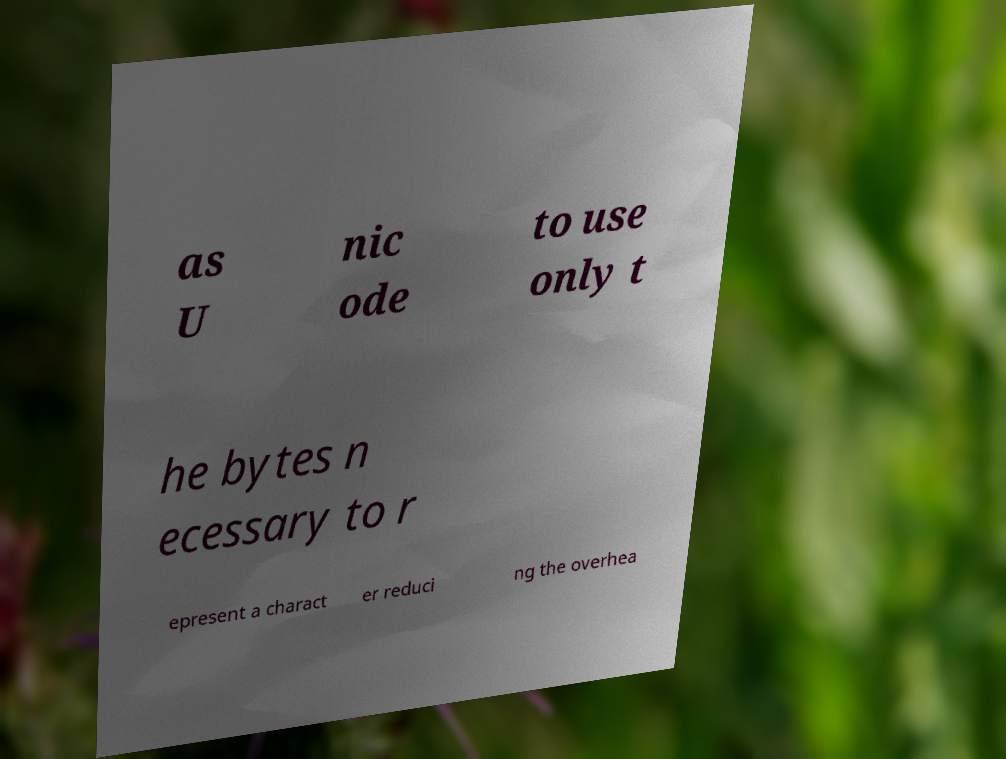Could you extract and type out the text from this image? as U nic ode to use only t he bytes n ecessary to r epresent a charact er reduci ng the overhea 